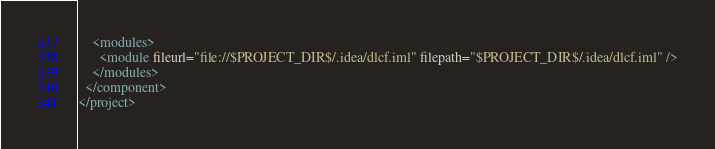<code> <loc_0><loc_0><loc_500><loc_500><_XML_>    <modules>
      <module fileurl="file://$PROJECT_DIR$/.idea/dlcf.iml" filepath="$PROJECT_DIR$/.idea/dlcf.iml" />
    </modules>
  </component>
</project>
</code> 